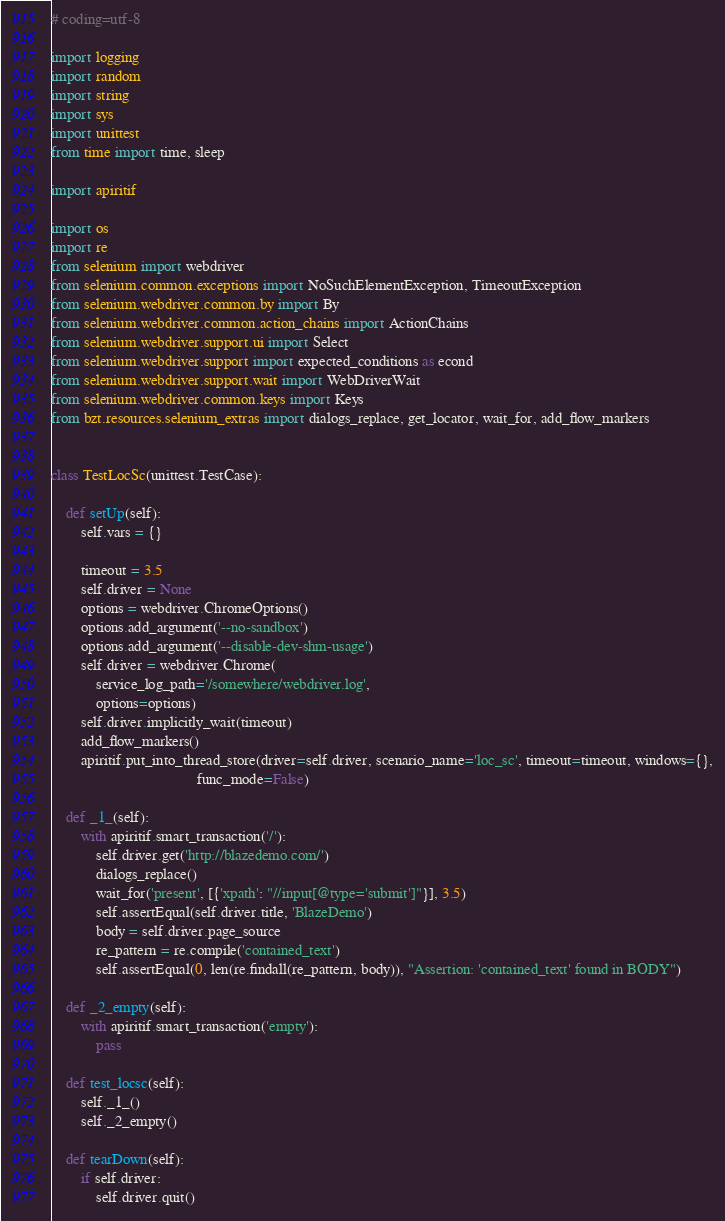<code> <loc_0><loc_0><loc_500><loc_500><_Python_># coding=utf-8

import logging
import random
import string
import sys
import unittest
from time import time, sleep

import apiritif

import os
import re
from selenium import webdriver
from selenium.common.exceptions import NoSuchElementException, TimeoutException
from selenium.webdriver.common.by import By
from selenium.webdriver.common.action_chains import ActionChains
from selenium.webdriver.support.ui import Select
from selenium.webdriver.support import expected_conditions as econd
from selenium.webdriver.support.wait import WebDriverWait
from selenium.webdriver.common.keys import Keys
from bzt.resources.selenium_extras import dialogs_replace, get_locator, wait_for, add_flow_markers


class TestLocSc(unittest.TestCase):

    def setUp(self):
        self.vars = {}

        timeout = 3.5
        self.driver = None
        options = webdriver.ChromeOptions()
        options.add_argument('--no-sandbox')
        options.add_argument('--disable-dev-shm-usage')
        self.driver = webdriver.Chrome(
            service_log_path='/somewhere/webdriver.log',
            options=options)
        self.driver.implicitly_wait(timeout)
        add_flow_markers()
        apiritif.put_into_thread_store(driver=self.driver, scenario_name='loc_sc', timeout=timeout, windows={},
                                       func_mode=False)

    def _1_(self):
        with apiritif.smart_transaction('/'):
            self.driver.get('http://blazedemo.com/')
            dialogs_replace()
            wait_for('present', [{'xpath': "//input[@type='submit']"}], 3.5)
            self.assertEqual(self.driver.title, 'BlazeDemo')
            body = self.driver.page_source
            re_pattern = re.compile('contained_text')
            self.assertEqual(0, len(re.findall(re_pattern, body)), "Assertion: 'contained_text' found in BODY")

    def _2_empty(self):
        with apiritif.smart_transaction('empty'):
            pass

    def test_locsc(self):
        self._1_()
        self._2_empty()

    def tearDown(self):
        if self.driver:
            self.driver.quit()
</code> 